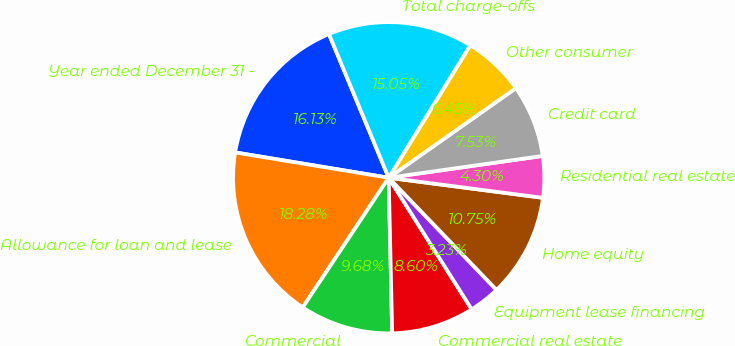Convert chart to OTSL. <chart><loc_0><loc_0><loc_500><loc_500><pie_chart><fcel>Year ended December 31 -<fcel>Allowance for loan and lease<fcel>Commercial<fcel>Commercial real estate<fcel>Equipment lease financing<fcel>Home equity<fcel>Residential real estate<fcel>Credit card<fcel>Other consumer<fcel>Total charge-offs<nl><fcel>16.13%<fcel>18.28%<fcel>9.68%<fcel>8.6%<fcel>3.23%<fcel>10.75%<fcel>4.3%<fcel>7.53%<fcel>6.45%<fcel>15.05%<nl></chart> 